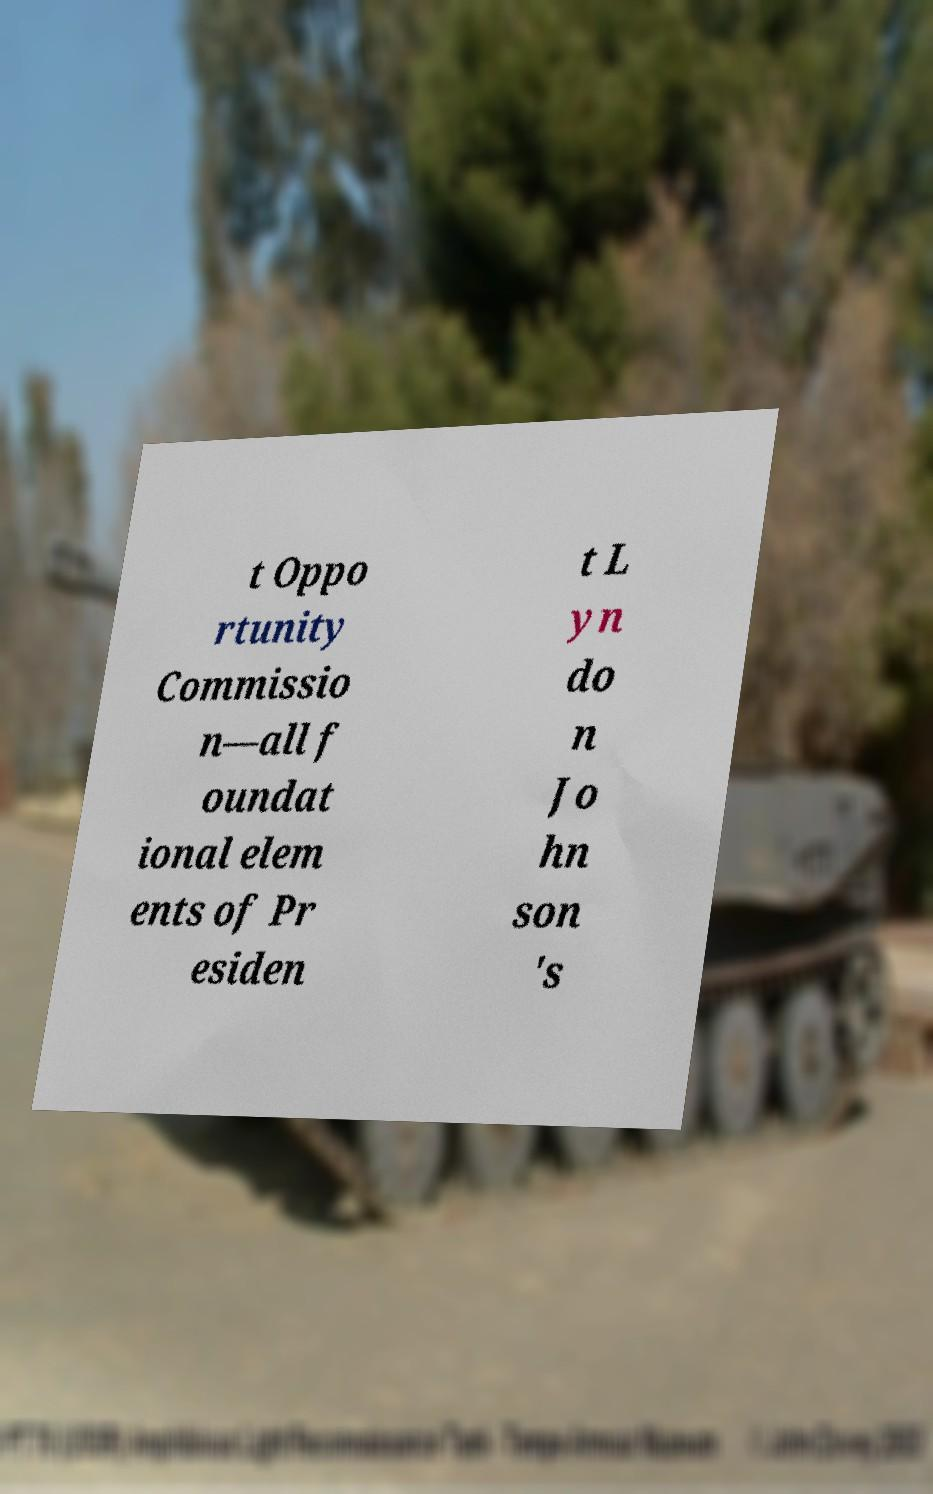For documentation purposes, I need the text within this image transcribed. Could you provide that? t Oppo rtunity Commissio n—all f oundat ional elem ents of Pr esiden t L yn do n Jo hn son 's 